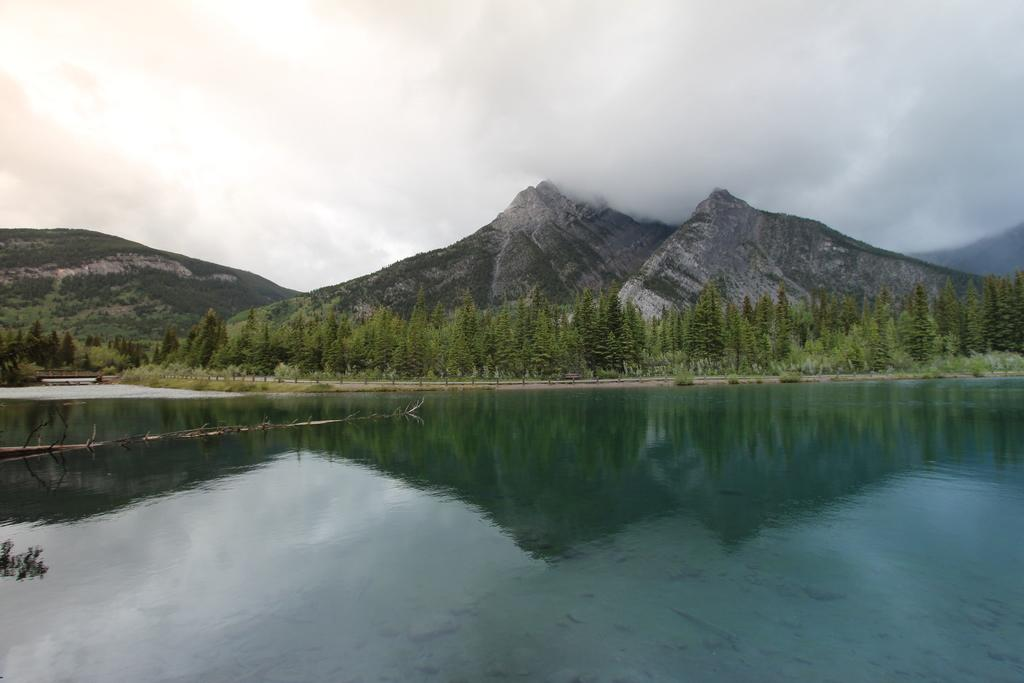What is the primary element visible in the image? There is a water surface in the image. What can be seen behind the water surface? There are trees and mountains visible behind the water surface. What type of connection can be seen between the trees and the mountains in the image? There is no specific connection between the trees and the mountains mentioned in the image; they are simply visible behind the water surface. 